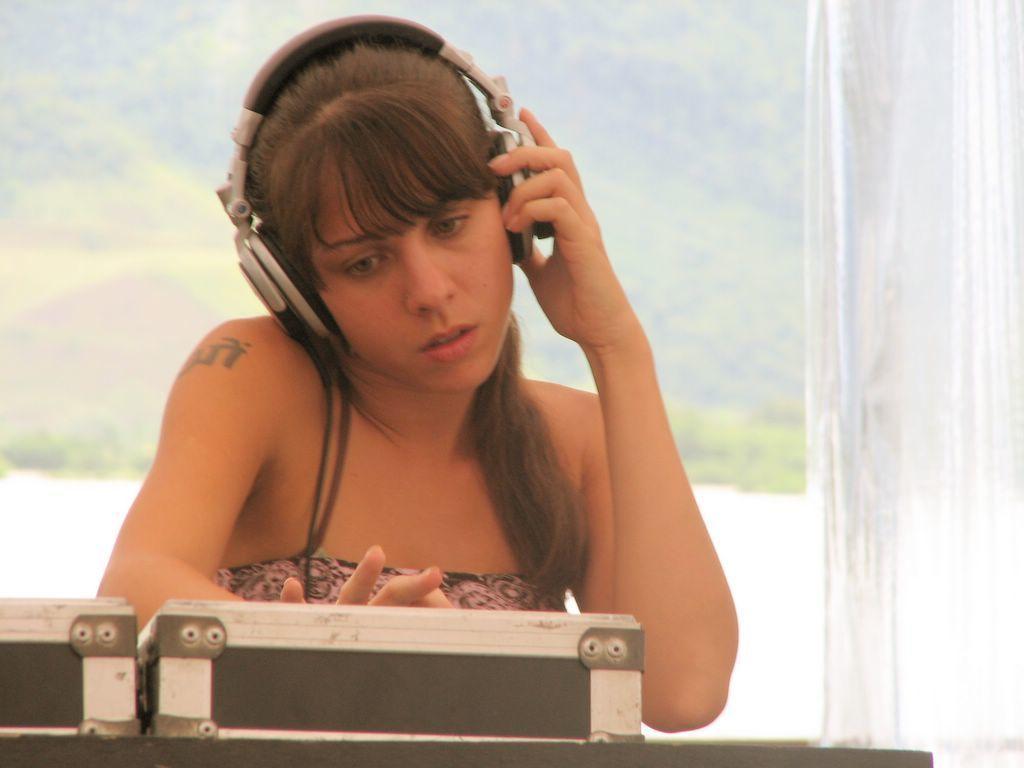How would you summarize this image in a sentence or two? This image is taken outdoors. At the bottom of the image there is a table with a music player on it. In the middle of the image a woman is playing DJ. She has worn a headset. In the background there are many trees and plants. 